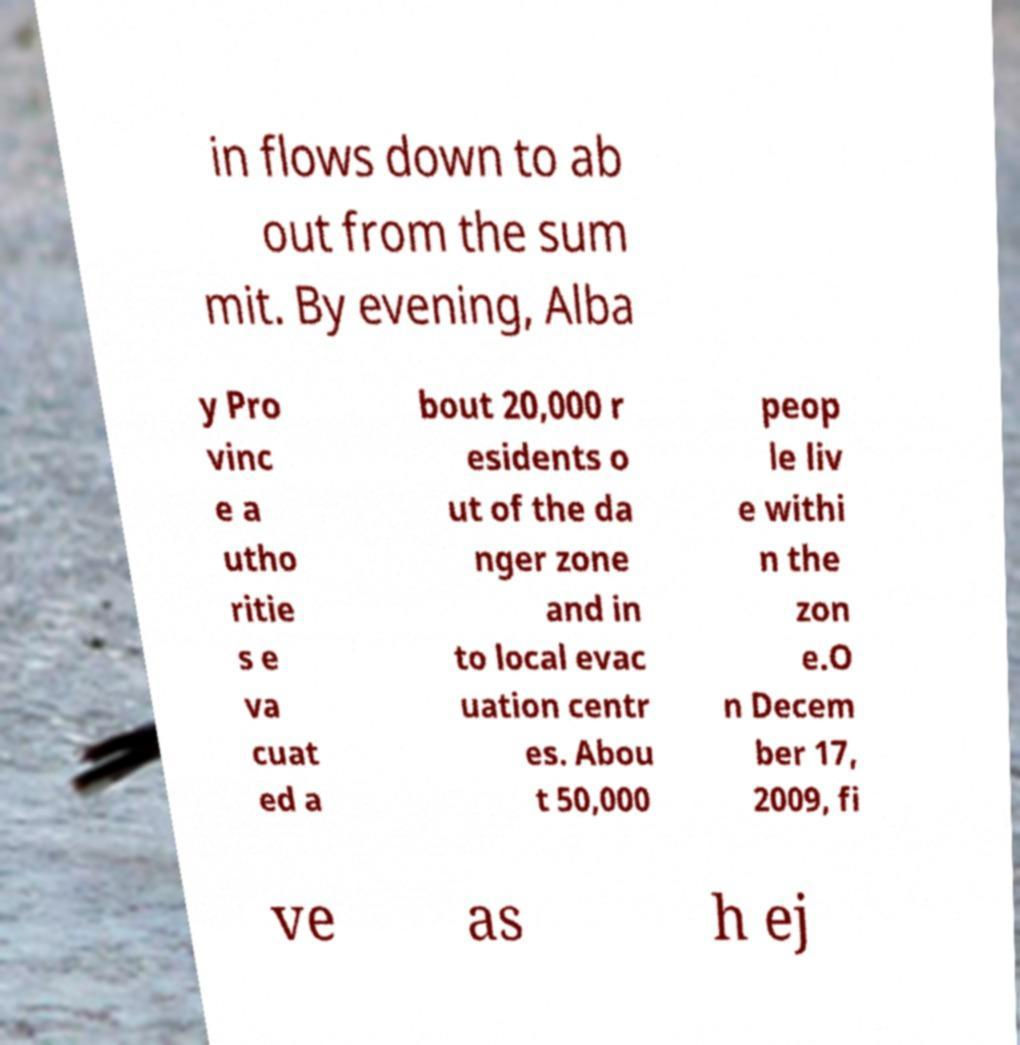Please read and relay the text visible in this image. What does it say? in flows down to ab out from the sum mit. By evening, Alba y Pro vinc e a utho ritie s e va cuat ed a bout 20,000 r esidents o ut of the da nger zone and in to local evac uation centr es. Abou t 50,000 peop le liv e withi n the zon e.O n Decem ber 17, 2009, fi ve as h ej 